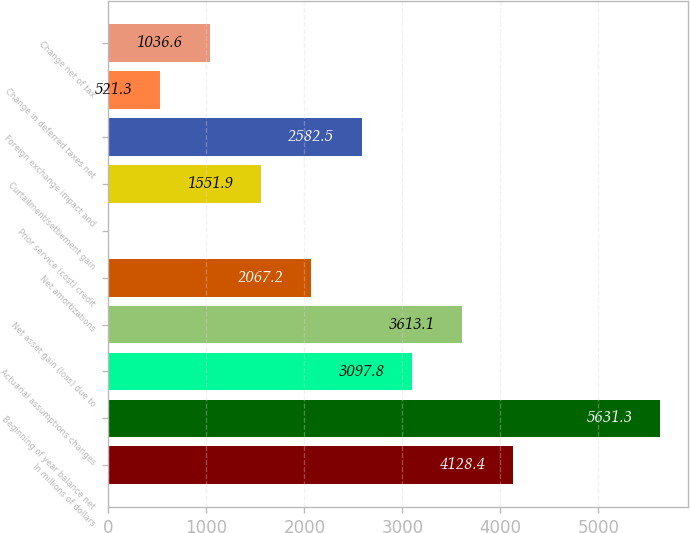Convert chart to OTSL. <chart><loc_0><loc_0><loc_500><loc_500><bar_chart><fcel>In millions of dollars<fcel>Beginning of year balance net<fcel>Actuarial assumptions changes<fcel>Net asset gain (loss) due to<fcel>Net amortizations<fcel>Prior service (cost) credit<fcel>Curtailment/settlement gain<fcel>Foreign exchange impact and<fcel>Change in deferred taxes net<fcel>Change net of tax<nl><fcel>4128.4<fcel>5631.3<fcel>3097.8<fcel>3613.1<fcel>2067.2<fcel>6<fcel>1551.9<fcel>2582.5<fcel>521.3<fcel>1036.6<nl></chart> 